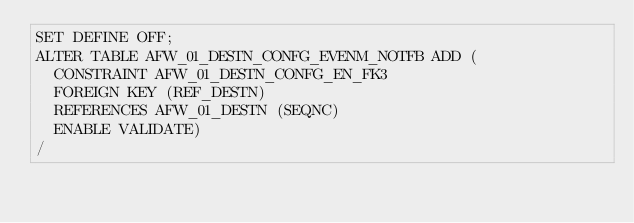<code> <loc_0><loc_0><loc_500><loc_500><_SQL_>SET DEFINE OFF;
ALTER TABLE AFW_01_DESTN_CONFG_EVENM_NOTFB ADD (
  CONSTRAINT AFW_01_DESTN_CONFG_EN_FK3 
  FOREIGN KEY (REF_DESTN) 
  REFERENCES AFW_01_DESTN (SEQNC)
  ENABLE VALIDATE)
/
</code> 